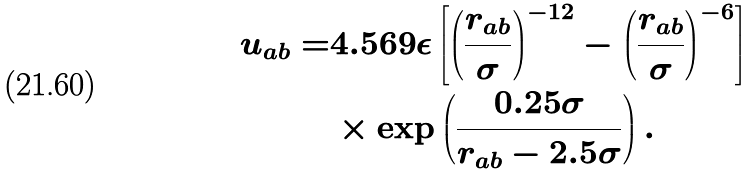<formula> <loc_0><loc_0><loc_500><loc_500>u _ { a b } = & 4 . 5 6 9 \epsilon \left [ \left ( \frac { r _ { a b } } { \sigma } \right ) ^ { - 1 2 } - \left ( \frac { r _ { a b } } { \sigma } \right ) ^ { - 6 } \right ] \\ & \times \exp \left ( \frac { 0 . 2 5 \sigma } { r _ { a b } - 2 . 5 \sigma } \right ) .</formula> 